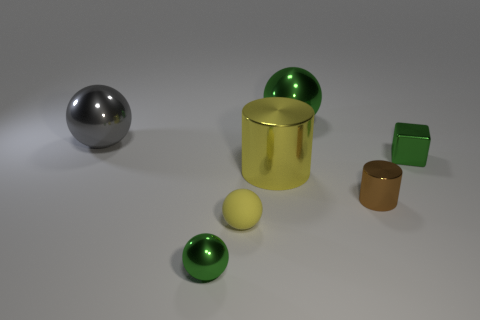Subtract all gray balls. How many balls are left? 3 Subtract all purple blocks. How many green spheres are left? 2 Subtract all gray balls. How many balls are left? 3 Subtract 1 balls. How many balls are left? 3 Add 2 gray objects. How many objects exist? 9 Subtract all red balls. Subtract all brown blocks. How many balls are left? 4 Add 2 spheres. How many spheres exist? 6 Subtract 0 blue blocks. How many objects are left? 7 Subtract all cylinders. How many objects are left? 5 Subtract all spheres. Subtract all small purple metallic blocks. How many objects are left? 3 